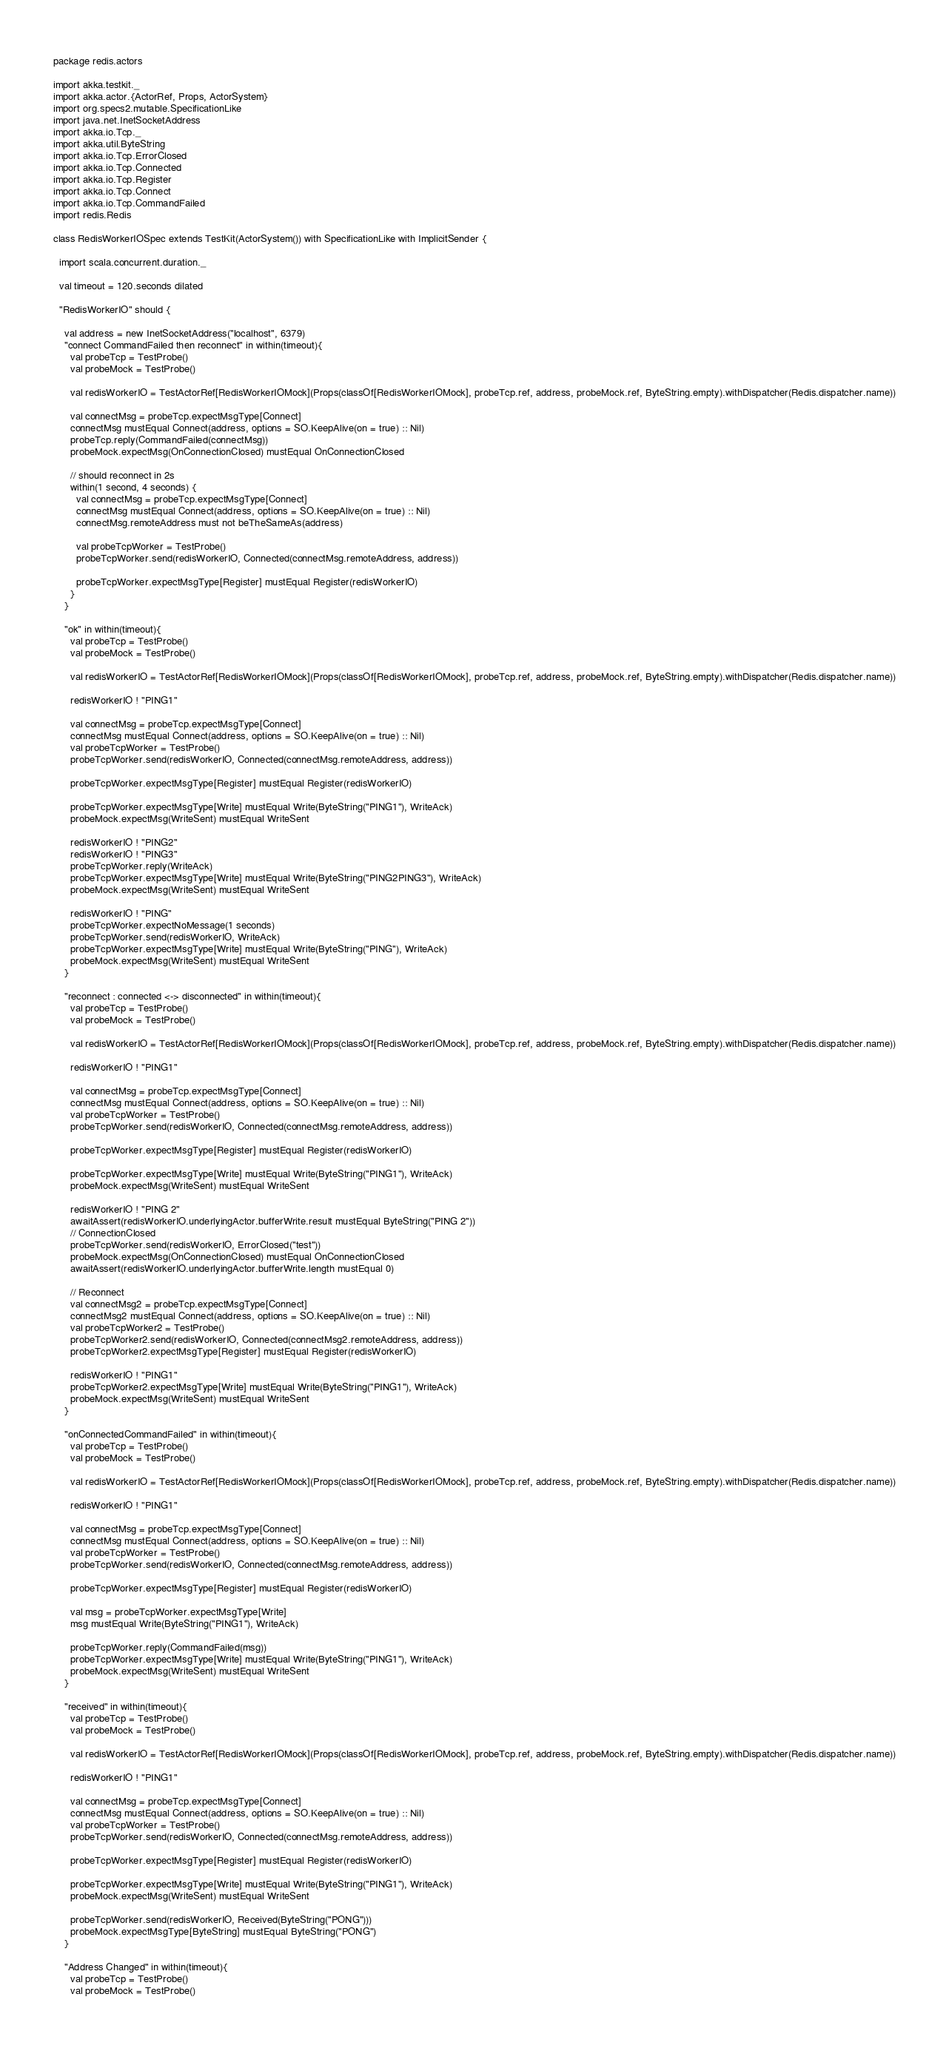<code> <loc_0><loc_0><loc_500><loc_500><_Scala_>package redis.actors

import akka.testkit._
import akka.actor.{ActorRef, Props, ActorSystem}
import org.specs2.mutable.SpecificationLike
import java.net.InetSocketAddress
import akka.io.Tcp._
import akka.util.ByteString
import akka.io.Tcp.ErrorClosed
import akka.io.Tcp.Connected
import akka.io.Tcp.Register
import akka.io.Tcp.Connect
import akka.io.Tcp.CommandFailed
import redis.Redis

class RedisWorkerIOSpec extends TestKit(ActorSystem()) with SpecificationLike with ImplicitSender {

  import scala.concurrent.duration._

  val timeout = 120.seconds dilated

  "RedisWorkerIO" should {

    val address = new InetSocketAddress("localhost", 6379)
    "connect CommandFailed then reconnect" in within(timeout){
      val probeTcp = TestProbe()
      val probeMock = TestProbe()

      val redisWorkerIO = TestActorRef[RedisWorkerIOMock](Props(classOf[RedisWorkerIOMock], probeTcp.ref, address, probeMock.ref, ByteString.empty).withDispatcher(Redis.dispatcher.name))

      val connectMsg = probeTcp.expectMsgType[Connect]
      connectMsg mustEqual Connect(address, options = SO.KeepAlive(on = true) :: Nil)
      probeTcp.reply(CommandFailed(connectMsg))
      probeMock.expectMsg(OnConnectionClosed) mustEqual OnConnectionClosed

      // should reconnect in 2s
      within(1 second, 4 seconds) {
        val connectMsg = probeTcp.expectMsgType[Connect]
        connectMsg mustEqual Connect(address, options = SO.KeepAlive(on = true) :: Nil)
        connectMsg.remoteAddress must not beTheSameAs(address)

        val probeTcpWorker = TestProbe()
        probeTcpWorker.send(redisWorkerIO, Connected(connectMsg.remoteAddress, address))

        probeTcpWorker.expectMsgType[Register] mustEqual Register(redisWorkerIO)
      }
    }

    "ok" in within(timeout){
      val probeTcp = TestProbe()
      val probeMock = TestProbe()

      val redisWorkerIO = TestActorRef[RedisWorkerIOMock](Props(classOf[RedisWorkerIOMock], probeTcp.ref, address, probeMock.ref, ByteString.empty).withDispatcher(Redis.dispatcher.name))

      redisWorkerIO ! "PING1"

      val connectMsg = probeTcp.expectMsgType[Connect]
      connectMsg mustEqual Connect(address, options = SO.KeepAlive(on = true) :: Nil)
      val probeTcpWorker = TestProbe()
      probeTcpWorker.send(redisWorkerIO, Connected(connectMsg.remoteAddress, address))

      probeTcpWorker.expectMsgType[Register] mustEqual Register(redisWorkerIO)

      probeTcpWorker.expectMsgType[Write] mustEqual Write(ByteString("PING1"), WriteAck)
      probeMock.expectMsg(WriteSent) mustEqual WriteSent

      redisWorkerIO ! "PING2"
      redisWorkerIO ! "PING3"
      probeTcpWorker.reply(WriteAck)
      probeTcpWorker.expectMsgType[Write] mustEqual Write(ByteString("PING2PING3"), WriteAck)
      probeMock.expectMsg(WriteSent) mustEqual WriteSent

      redisWorkerIO ! "PING"
      probeTcpWorker.expectNoMessage(1 seconds)
      probeTcpWorker.send(redisWorkerIO, WriteAck)
      probeTcpWorker.expectMsgType[Write] mustEqual Write(ByteString("PING"), WriteAck)
      probeMock.expectMsg(WriteSent) mustEqual WriteSent
    }

    "reconnect : connected <-> disconnected" in within(timeout){
      val probeTcp = TestProbe()
      val probeMock = TestProbe()

      val redisWorkerIO = TestActorRef[RedisWorkerIOMock](Props(classOf[RedisWorkerIOMock], probeTcp.ref, address, probeMock.ref, ByteString.empty).withDispatcher(Redis.dispatcher.name))

      redisWorkerIO ! "PING1"

      val connectMsg = probeTcp.expectMsgType[Connect]
      connectMsg mustEqual Connect(address, options = SO.KeepAlive(on = true) :: Nil)
      val probeTcpWorker = TestProbe()
      probeTcpWorker.send(redisWorkerIO, Connected(connectMsg.remoteAddress, address))

      probeTcpWorker.expectMsgType[Register] mustEqual Register(redisWorkerIO)

      probeTcpWorker.expectMsgType[Write] mustEqual Write(ByteString("PING1"), WriteAck)
      probeMock.expectMsg(WriteSent) mustEqual WriteSent

      redisWorkerIO ! "PING 2"
      awaitAssert(redisWorkerIO.underlyingActor.bufferWrite.result mustEqual ByteString("PING 2"))
      // ConnectionClosed
      probeTcpWorker.send(redisWorkerIO, ErrorClosed("test"))
      probeMock.expectMsg(OnConnectionClosed) mustEqual OnConnectionClosed
      awaitAssert(redisWorkerIO.underlyingActor.bufferWrite.length mustEqual 0)

      // Reconnect
      val connectMsg2 = probeTcp.expectMsgType[Connect]
      connectMsg2 mustEqual Connect(address, options = SO.KeepAlive(on = true) :: Nil)
      val probeTcpWorker2 = TestProbe()
      probeTcpWorker2.send(redisWorkerIO, Connected(connectMsg2.remoteAddress, address))
      probeTcpWorker2.expectMsgType[Register] mustEqual Register(redisWorkerIO)

      redisWorkerIO ! "PING1"
      probeTcpWorker2.expectMsgType[Write] mustEqual Write(ByteString("PING1"), WriteAck)
      probeMock.expectMsg(WriteSent) mustEqual WriteSent
    }

    "onConnectedCommandFailed" in within(timeout){
      val probeTcp = TestProbe()
      val probeMock = TestProbe()

      val redisWorkerIO = TestActorRef[RedisWorkerIOMock](Props(classOf[RedisWorkerIOMock], probeTcp.ref, address, probeMock.ref, ByteString.empty).withDispatcher(Redis.dispatcher.name))

      redisWorkerIO ! "PING1"

      val connectMsg = probeTcp.expectMsgType[Connect]
      connectMsg mustEqual Connect(address, options = SO.KeepAlive(on = true) :: Nil)
      val probeTcpWorker = TestProbe()
      probeTcpWorker.send(redisWorkerIO, Connected(connectMsg.remoteAddress, address))

      probeTcpWorker.expectMsgType[Register] mustEqual Register(redisWorkerIO)

      val msg = probeTcpWorker.expectMsgType[Write]
      msg mustEqual Write(ByteString("PING1"), WriteAck)

      probeTcpWorker.reply(CommandFailed(msg))
      probeTcpWorker.expectMsgType[Write] mustEqual Write(ByteString("PING1"), WriteAck)
      probeMock.expectMsg(WriteSent) mustEqual WriteSent
    }

    "received" in within(timeout){
      val probeTcp = TestProbe()
      val probeMock = TestProbe()

      val redisWorkerIO = TestActorRef[RedisWorkerIOMock](Props(classOf[RedisWorkerIOMock], probeTcp.ref, address, probeMock.ref, ByteString.empty).withDispatcher(Redis.dispatcher.name))

      redisWorkerIO ! "PING1"

      val connectMsg = probeTcp.expectMsgType[Connect]
      connectMsg mustEqual Connect(address, options = SO.KeepAlive(on = true) :: Nil)
      val probeTcpWorker = TestProbe()
      probeTcpWorker.send(redisWorkerIO, Connected(connectMsg.remoteAddress, address))

      probeTcpWorker.expectMsgType[Register] mustEqual Register(redisWorkerIO)

      probeTcpWorker.expectMsgType[Write] mustEqual Write(ByteString("PING1"), WriteAck)
      probeMock.expectMsg(WriteSent) mustEqual WriteSent

      probeTcpWorker.send(redisWorkerIO, Received(ByteString("PONG")))
      probeMock.expectMsgType[ByteString] mustEqual ByteString("PONG")
    }

    "Address Changed" in within(timeout){
      val probeTcp = TestProbe()
      val probeMock = TestProbe()
</code> 